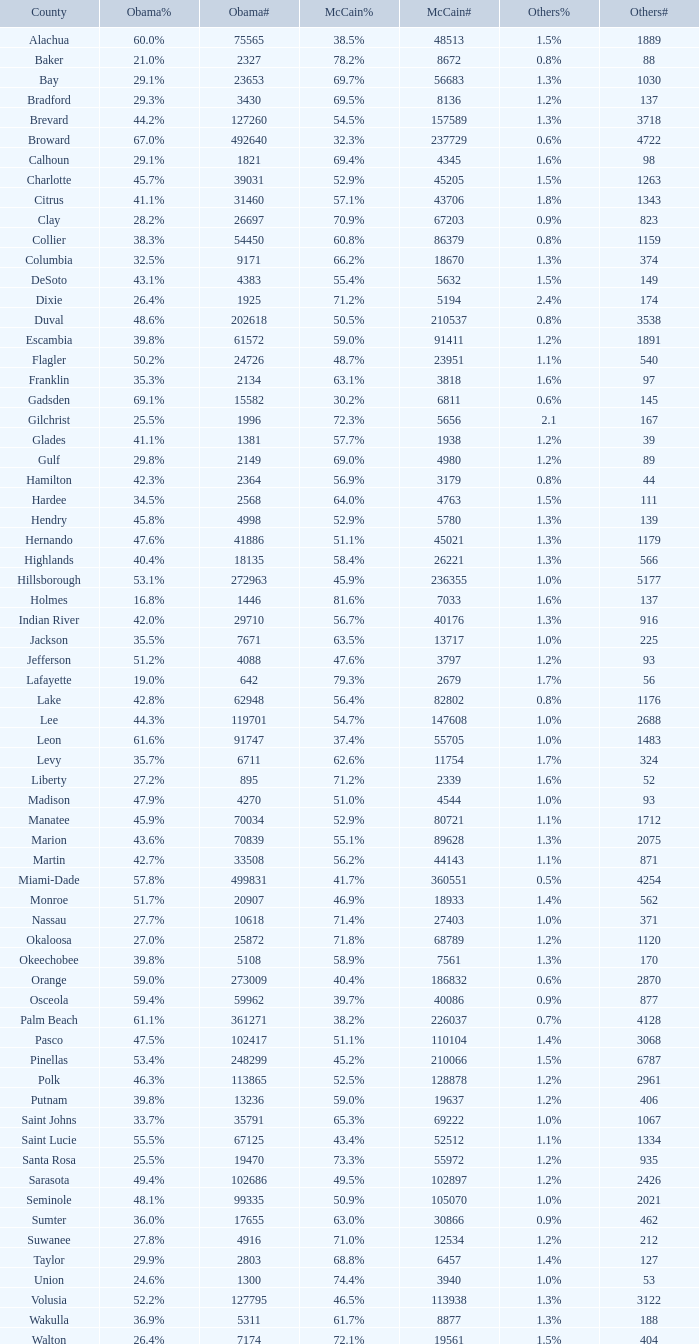How many numbers were recorded under McCain when Obama had 27.2% voters? 1.0. 